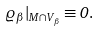<formula> <loc_0><loc_0><loc_500><loc_500>\varrho _ { \beta } | _ { M \cap V _ { \beta } } \equiv 0 .</formula> 